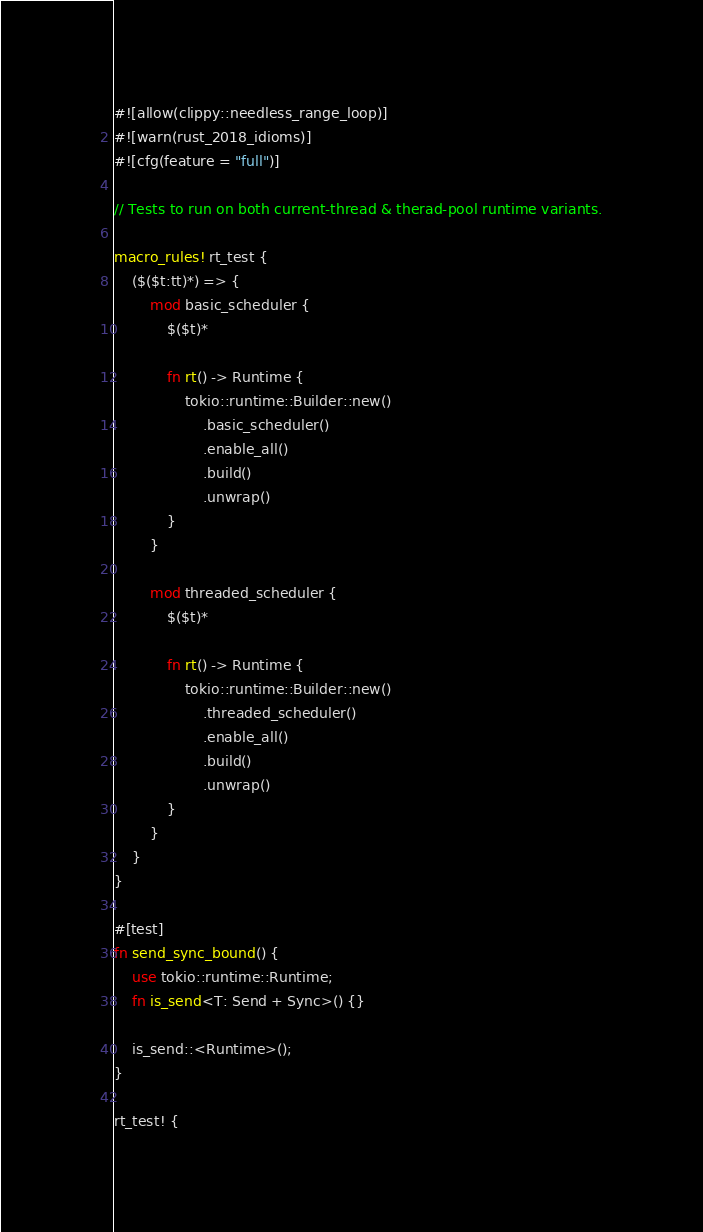<code> <loc_0><loc_0><loc_500><loc_500><_Rust_>#![allow(clippy::needless_range_loop)]
#![warn(rust_2018_idioms)]
#![cfg(feature = "full")]

// Tests to run on both current-thread & therad-pool runtime variants.

macro_rules! rt_test {
    ($($t:tt)*) => {
        mod basic_scheduler {
            $($t)*

            fn rt() -> Runtime {
                tokio::runtime::Builder::new()
                    .basic_scheduler()
                    .enable_all()
                    .build()
                    .unwrap()
            }
        }

        mod threaded_scheduler {
            $($t)*

            fn rt() -> Runtime {
                tokio::runtime::Builder::new()
                    .threaded_scheduler()
                    .enable_all()
                    .build()
                    .unwrap()
            }
        }
    }
}

#[test]
fn send_sync_bound() {
    use tokio::runtime::Runtime;
    fn is_send<T: Send + Sync>() {}

    is_send::<Runtime>();
}

rt_test! {</code> 